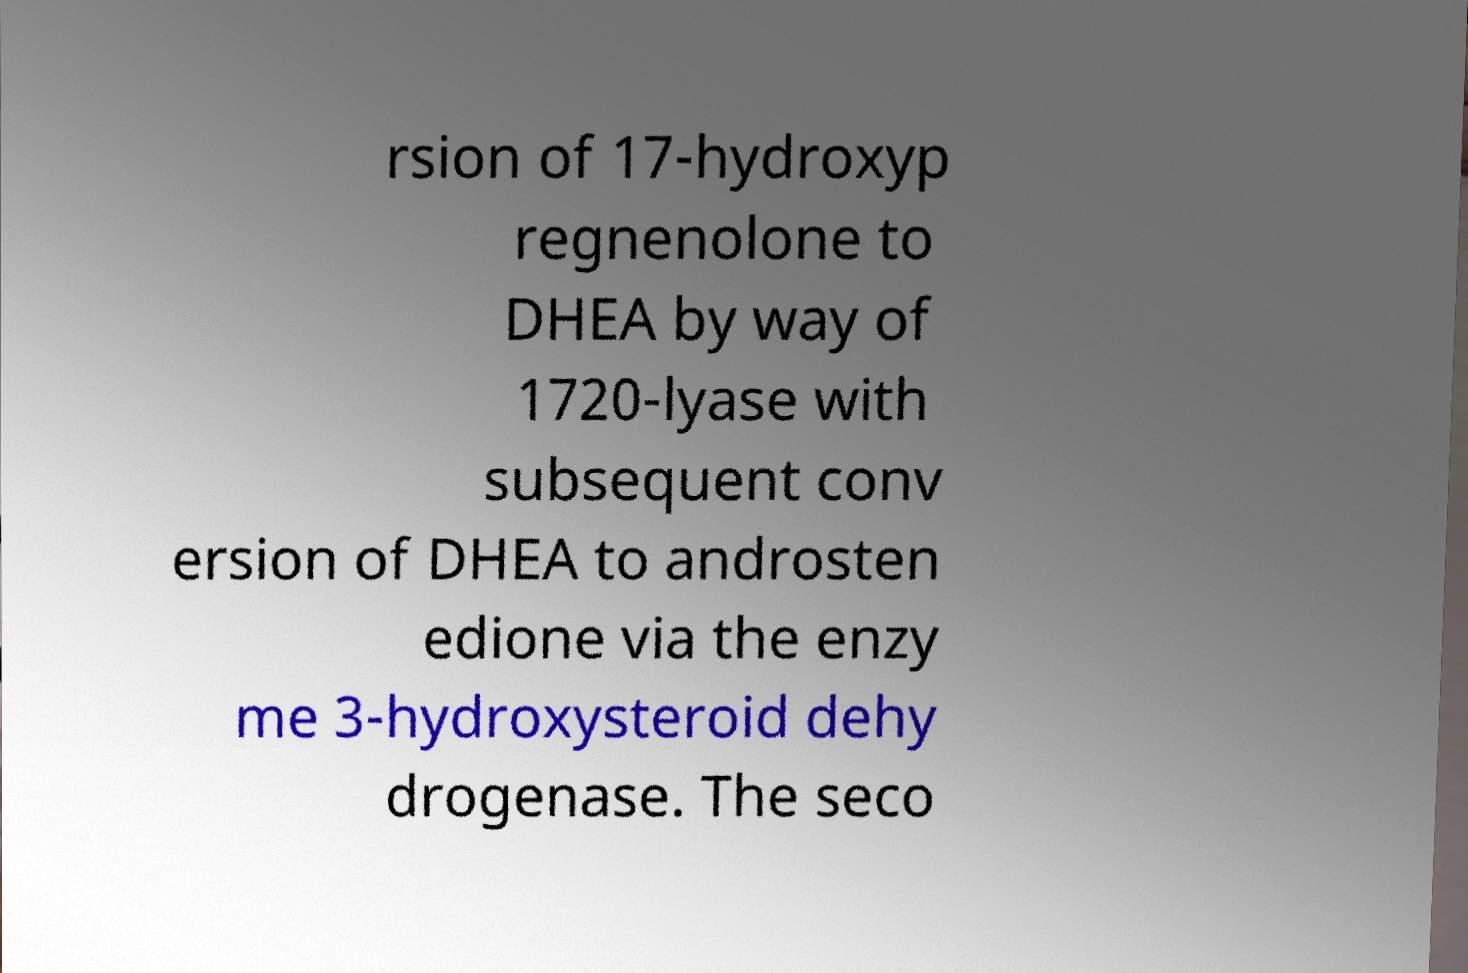What messages or text are displayed in this image? I need them in a readable, typed format. rsion of 17-hydroxyp regnenolone to DHEA by way of 1720-lyase with subsequent conv ersion of DHEA to androsten edione via the enzy me 3-hydroxysteroid dehy drogenase. The seco 